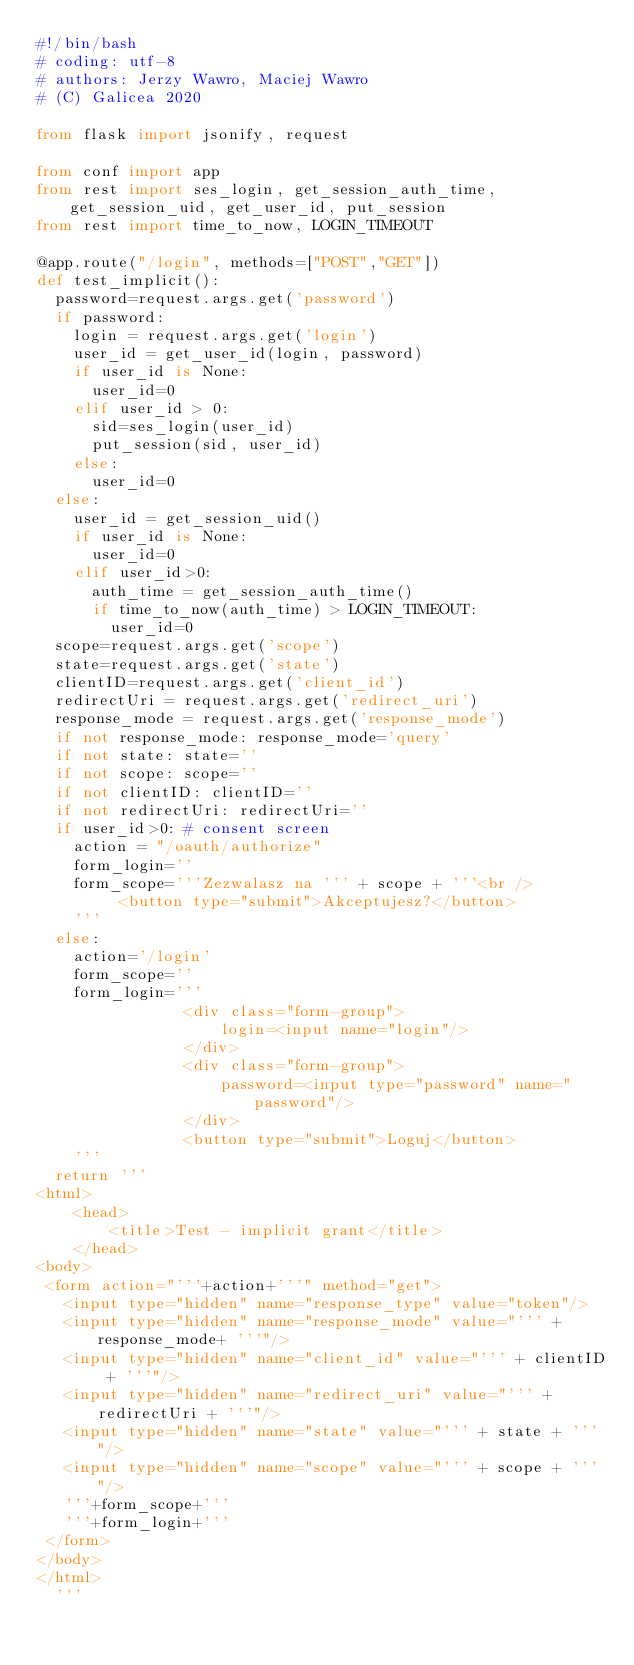Convert code to text. <code><loc_0><loc_0><loc_500><loc_500><_Python_>#!/bin/bash
# coding: utf-8
# authors: Jerzy Wawro, Maciej Wawro
# (C) Galicea 2020

from flask import jsonify, request

from conf import app
from rest import ses_login, get_session_auth_time, get_session_uid, get_user_id, put_session
from rest import time_to_now, LOGIN_TIMEOUT

@app.route("/login", methods=["POST","GET"])
def test_implicit():
  password=request.args.get('password')
  if password:
    login = request.args.get('login')
    user_id = get_user_id(login, password)
    if user_id is None:
      user_id=0
    elif user_id > 0:
      sid=ses_login(user_id)
      put_session(sid, user_id)
    else:
      user_id=0
  else:
    user_id = get_session_uid()
    if user_id is None:
      user_id=0
    elif user_id>0:
      auth_time = get_session_auth_time()
      if time_to_now(auth_time) > LOGIN_TIMEOUT:
        user_id=0
  scope=request.args.get('scope')
  state=request.args.get('state')
  clientID=request.args.get('client_id')
  redirectUri = request.args.get('redirect_uri')
  response_mode = request.args.get('response_mode')
  if not response_mode: response_mode='query'
  if not state: state=''
  if not scope: scope=''
  if not clientID: clientID=''
  if not redirectUri: redirectUri=''
  if user_id>0: # consent screen
    action = "/oauth/authorize"
    form_login=''
    form_scope='''Zezwalasz na ''' + scope + '''<br />
         <button type="submit">Akceptujesz?</button>
    '''
  else:
    action='/login' 
    form_scope=''
    form_login='''
                <div class="form-group">
                    login=<input name="login"/>
                </div>
                <div class="form-group">
                    password=<input type="password" name="password"/>
                </div>
                <button type="submit">Loguj</button>
    '''
  return '''
<html>
    <head>
        <title>Test - implicit grant</title>
    </head>
<body>
 <form action="'''+action+'''" method="get">
   <input type="hidden" name="response_type" value="token"/>
   <input type="hidden" name="response_mode" value="''' + response_mode+ '''"/>
   <input type="hidden" name="client_id" value="''' + clientID + '''"/>
   <input type="hidden" name="redirect_uri" value="''' + redirectUri + '''"/>
   <input type="hidden" name="state" value="''' + state + '''"/>
   <input type="hidden" name="scope" value="''' + scope + '''"/>
   '''+form_scope+'''
   '''+form_login+'''
 </form>
</body>
</html>
  '''
</code> 